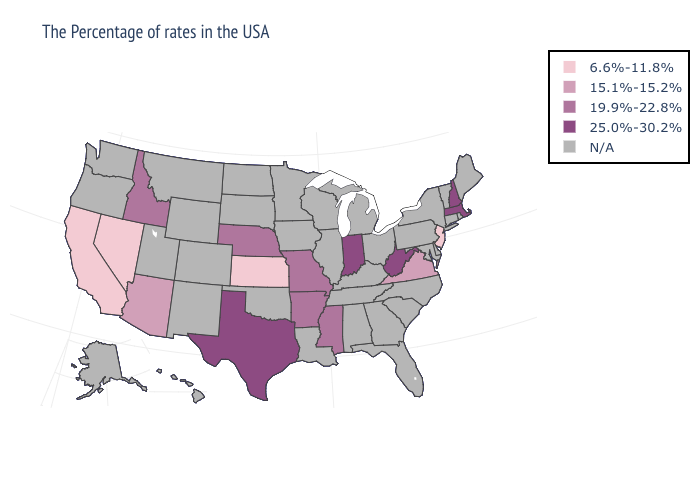Name the states that have a value in the range 15.1%-15.2%?
Write a very short answer. Virginia, Arizona. What is the value of Alaska?
Concise answer only. N/A. What is the highest value in the Northeast ?
Give a very brief answer. 25.0%-30.2%. Which states have the lowest value in the Northeast?
Concise answer only. New Jersey. What is the value of Maryland?
Write a very short answer. N/A. Does the first symbol in the legend represent the smallest category?
Keep it brief. Yes. What is the value of California?
Short answer required. 6.6%-11.8%. What is the value of New Jersey?
Give a very brief answer. 6.6%-11.8%. What is the value of Rhode Island?
Quick response, please. N/A. Name the states that have a value in the range 19.9%-22.8%?
Write a very short answer. Mississippi, Missouri, Arkansas, Nebraska, Idaho. Which states have the lowest value in the USA?
Give a very brief answer. New Jersey, Kansas, Nevada, California. What is the value of Maryland?
Quick response, please. N/A. 